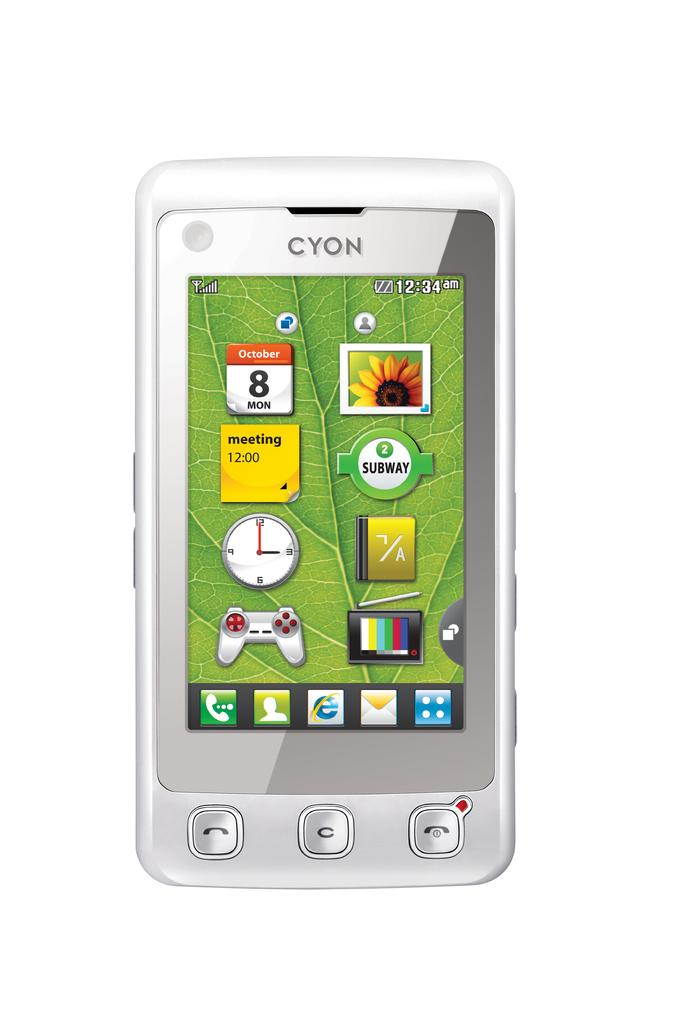<image>
Write a terse but informative summary of the picture. A white cell phone says Cyon on the top and shows the home screen. 